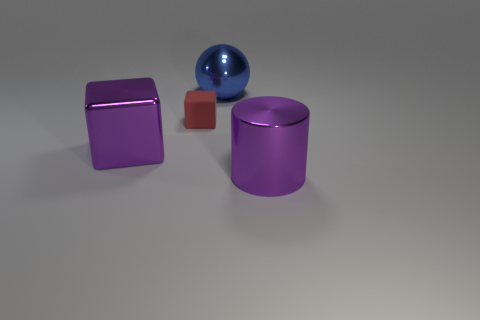Add 3 large cylinders. How many large cylinders exist? 4 Add 3 big spheres. How many objects exist? 7 Subtract 1 purple cubes. How many objects are left? 3 Subtract all cylinders. How many objects are left? 3 Subtract 1 blocks. How many blocks are left? 1 Subtract all green cubes. Subtract all cyan cylinders. How many cubes are left? 2 Subtract all cyan cylinders. How many purple cubes are left? 1 Subtract all matte objects. Subtract all big green objects. How many objects are left? 3 Add 3 large blue things. How many large blue things are left? 4 